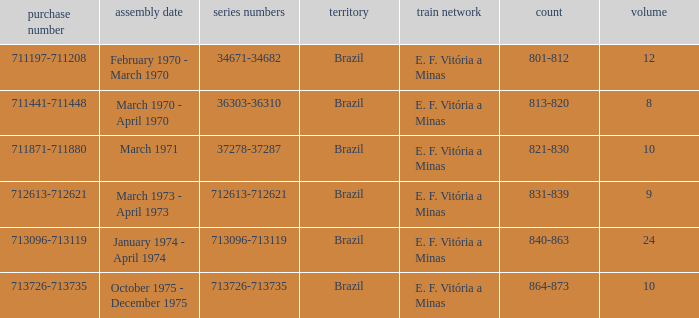The serial numbers 713096-713119 are in which country? Brazil. 